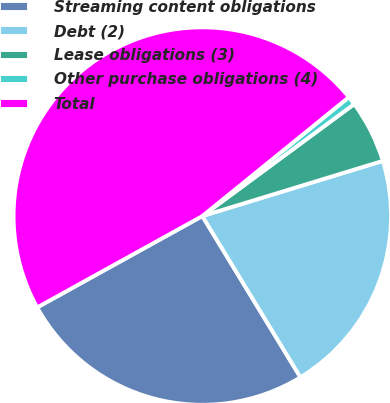Convert chart. <chart><loc_0><loc_0><loc_500><loc_500><pie_chart><fcel>Streaming content obligations<fcel>Debt (2)<fcel>Lease obligations (3)<fcel>Other purchase obligations (4)<fcel>Total<nl><fcel>25.66%<fcel>21.02%<fcel>5.39%<fcel>0.74%<fcel>47.19%<nl></chart> 